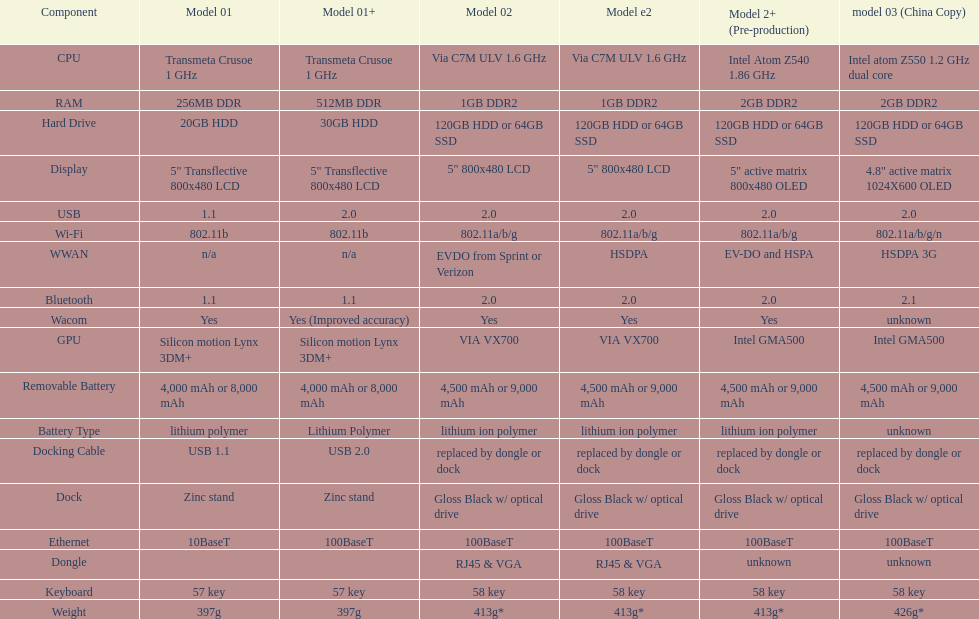What is the element preceding usb? Display. 